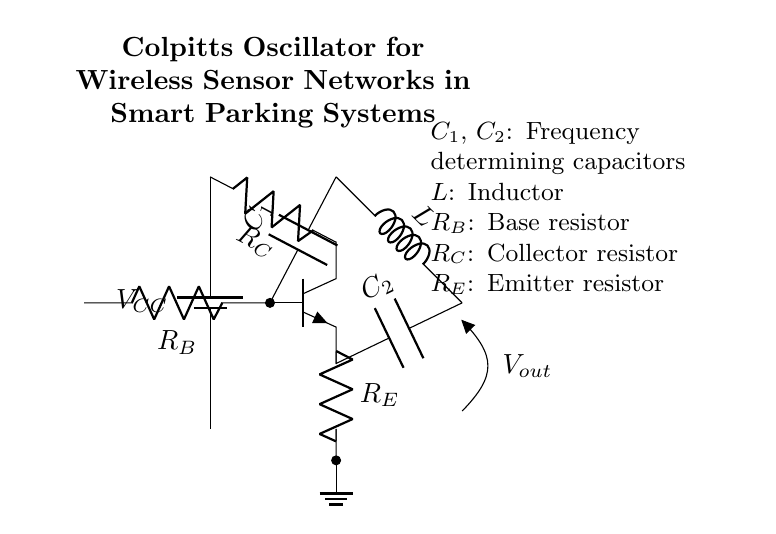What type of oscillator is shown in the diagram? The circuit diagram represents a Colpitts oscillator, characterized by its unique arrangement of capacitors and inductors for generating oscillatory signals.
Answer: Colpitts oscillator What are the frequency determining components? In this configuration, the capacitors C1 and C2 are responsible for determining the frequency of oscillation, as they interact with the inductor L in the feedback loop.
Answer: C1 and C2 How many resistors are present in the circuit? The circuit contains three resistors: R_B, R_C, and R_E, which play roles in biasing the transistor and controlling the overall gain.
Answer: Three What is the function of the inductor in the oscillator? The inductor L in a Colpitts oscillator is integral for creating the resonant frequency alongside the capacitors C1 and C2, allowing for sustained oscillation.
Answer: Resonance What would happen if C1 were increased in value? Increasing the value of C1 would decrease the frequency of oscillation, as larger capacitance leads to a lower resonant frequency given the same inductor value, according to the resonant frequency formula.
Answer: Decreased frequency Which component is connected to the collector of the transistor? The resistor R_C is connected to the collector of the transistor in this oscillator circuit, serving to control the collector current and overall output characteristics of the oscillator.
Answer: R_C What is the purpose of R_E in this configuration? Resistor R_E serves as the emitter resistor in the transistor, helping to stabilize the operating point and improve linearity by providing negative feedback.
Answer: Stabilization 